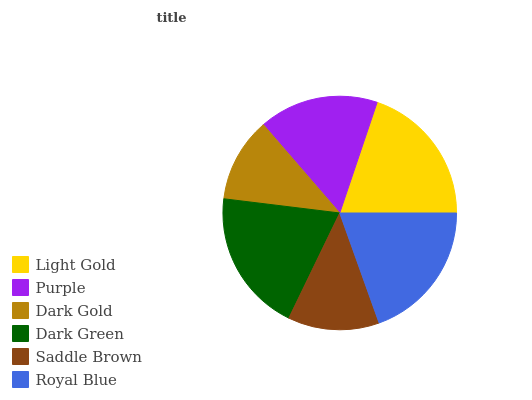Is Dark Gold the minimum?
Answer yes or no. Yes. Is Light Gold the maximum?
Answer yes or no. Yes. Is Purple the minimum?
Answer yes or no. No. Is Purple the maximum?
Answer yes or no. No. Is Light Gold greater than Purple?
Answer yes or no. Yes. Is Purple less than Light Gold?
Answer yes or no. Yes. Is Purple greater than Light Gold?
Answer yes or no. No. Is Light Gold less than Purple?
Answer yes or no. No. Is Royal Blue the high median?
Answer yes or no. Yes. Is Purple the low median?
Answer yes or no. Yes. Is Purple the high median?
Answer yes or no. No. Is Light Gold the low median?
Answer yes or no. No. 